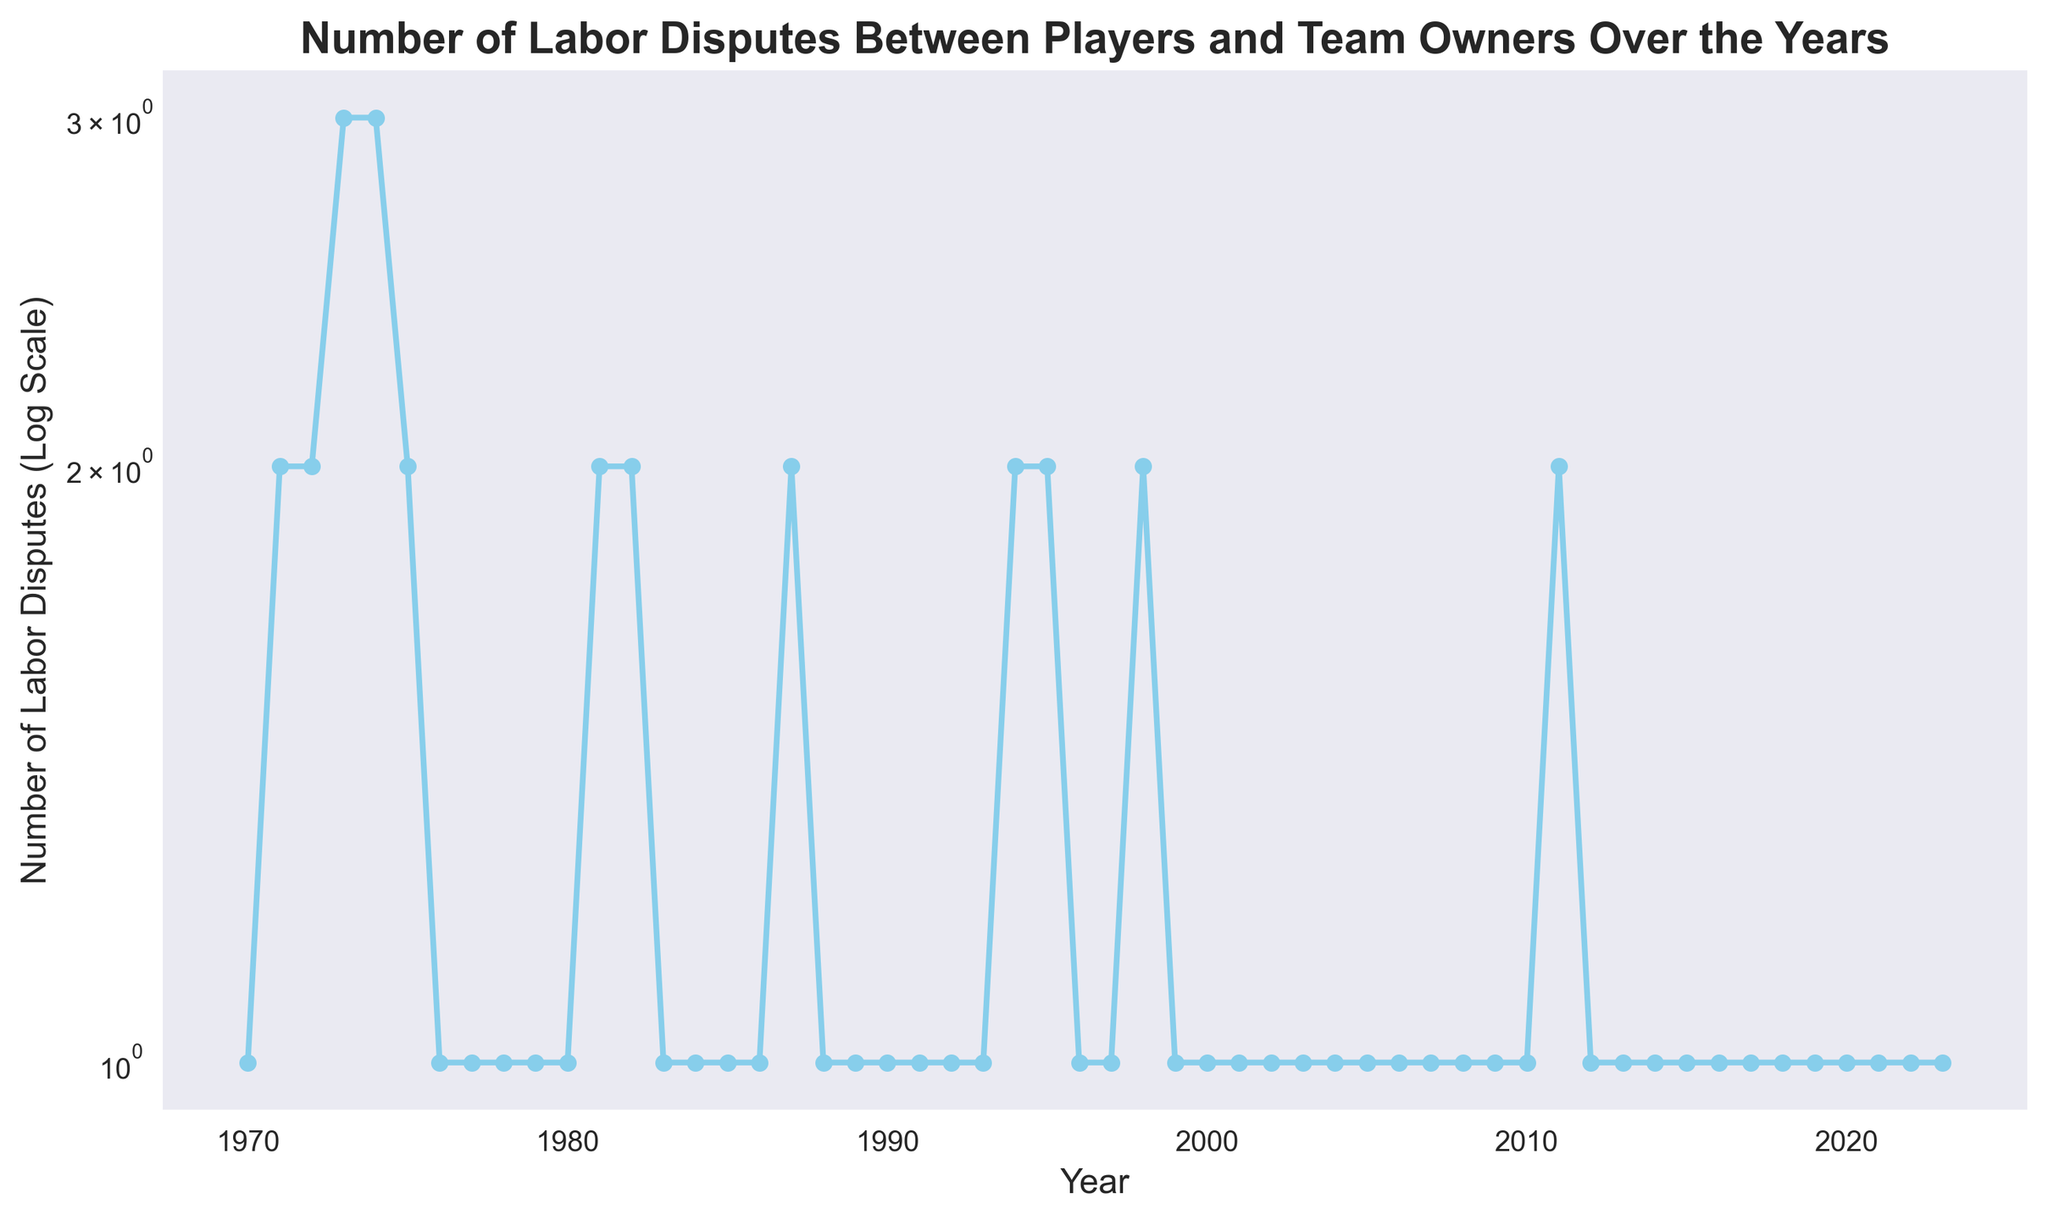What is the highest number of labor disputes in a single year? The highest number of labor disputes in a single year can be determined by observing the peak point on the plot. The highest point corresponds to a value of 3 disputes.
Answer: 3 In which years did the number of labor disputes reach 2? By looking at the plot, the data points that align with the value '2' can be identified. These years are 1971, 1972, 1981, 1982, 1987, 1994, 1995, 1998, and 2011.
Answer: 1971, 1972, 1981, 1982, 1987, 1994, 1995, 1998, 2011 How does the number of labor disputes in 1980 compare to that in 1987? By examining the plot, we observe that the number of labor disputes in 1980 is 1 and in 1987 it is 2. Therefore, the number of disputes in 1987 is greater than in 1980.
Answer: 1987 > 1980 What is the overall trend in the number of labor disputes from 1970 to 2023? Observing the plot from 1970 to 2023, the trend shows fluctuating values in the earlier years with occasional peaks, but overall, it appears relatively stable with values primarily at 1 in later years.
Answer: Relatively stable with occasional peaks How many years had exactly 1 labor dispute? Counting the years from the plot where the number of labor disputes is exactly 1, there are 42 years in total.
Answer: 42 Between which years did the number of labor disputes decrease from 3 to 1? On the plot, the significant drop from 3 to 1 occurs between the years 1974 and 1976. The count decreases from 3 in 1974 to 2 in 1975 and then to 1 in 1976.
Answer: 1974 to 1976 What’s the average number of labor disputes in the decade from 1980 to 1990? To find the average, sum the number of labor disputes from 1980 to 1990, which are (1+2+2+1+1+1+2+1+1+1) = 13. Then divide by the number of years, which is 11. The average is 13/11 ≈ 1.18
Answer: 1.18 Which year had the greatest decline in the number of labor disputes compared to the previous year? Observing the year-to-year differences on the plot, the greatest decline is between 1974 (3 disputes) and 1975 (2 disputes), resulting in a decrease of 1.
Answer: 1974 to 1975 After 2000, how many times did the number of labor disputes exceed 1? From the plot, it can be seen that after 2000, the number of labor disputes exceeded 1 only once, which occurred in 2011.
Answer: 1 